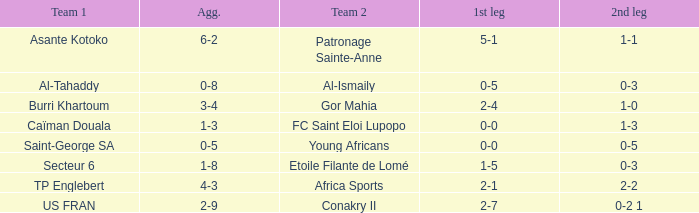What was the 2nd leg score between Patronage Sainte-Anne and Asante Kotoko? 1-1. Can you give me this table as a dict? {'header': ['Team 1', 'Agg.', 'Team 2', '1st leg', '2nd leg'], 'rows': [['Asante Kotoko', '6-2', 'Patronage Sainte-Anne', '5-1', '1-1'], ['Al-Tahaddy', '0-8', 'Al-Ismaily', '0-5', '0-3'], ['Burri Khartoum', '3-4', 'Gor Mahia', '2-4', '1-0'], ['Caïman Douala', '1-3', 'FC Saint Eloi Lupopo', '0-0', '1-3'], ['Saint-George SA', '0-5', 'Young Africans', '0-0', '0-5'], ['Secteur 6', '1-8', 'Etoile Filante de Lomé', '1-5', '0-3'], ['TP Englebert', '4-3', 'Africa Sports', '2-1', '2-2'], ['US FRAN', '2-9', 'Conakry II', '2-7', '0-2 1']]} 